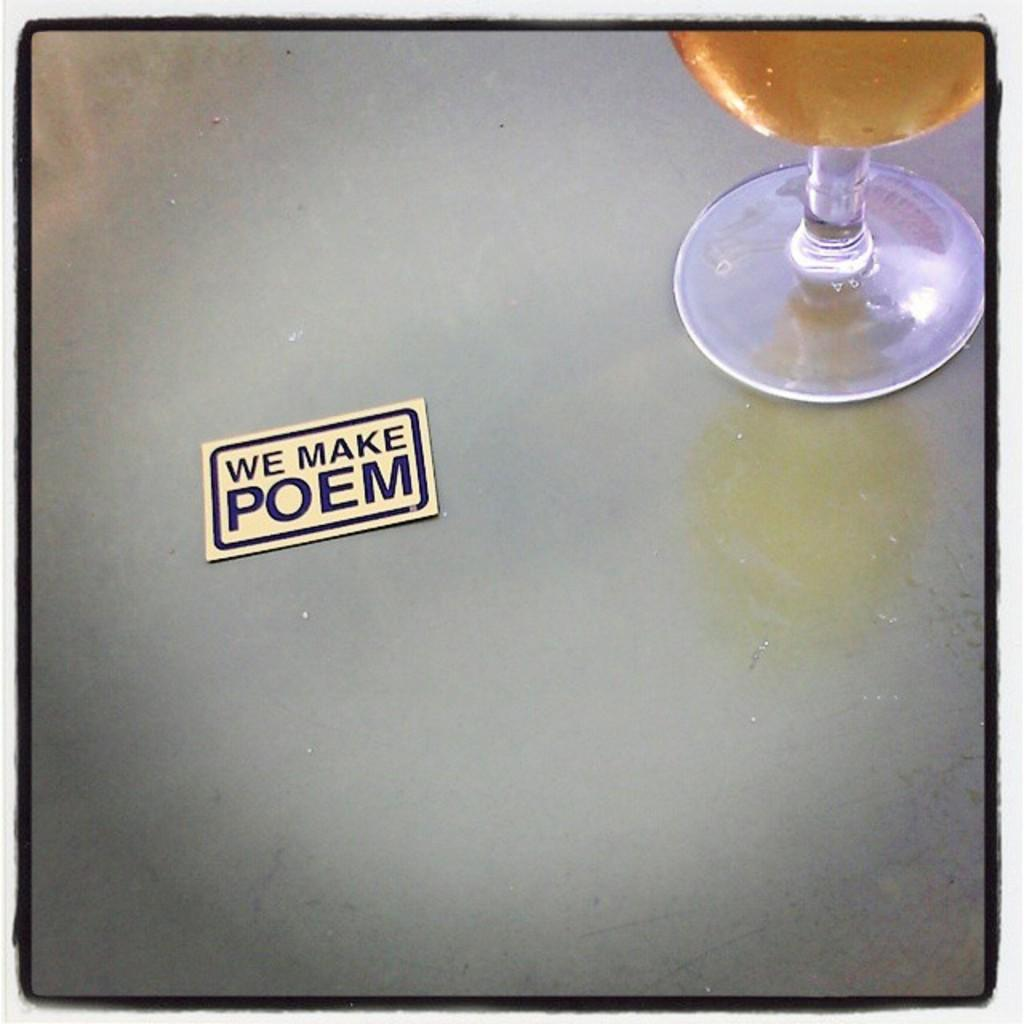<image>
Present a compact description of the photo's key features. A card on a table reading We Make Poem 